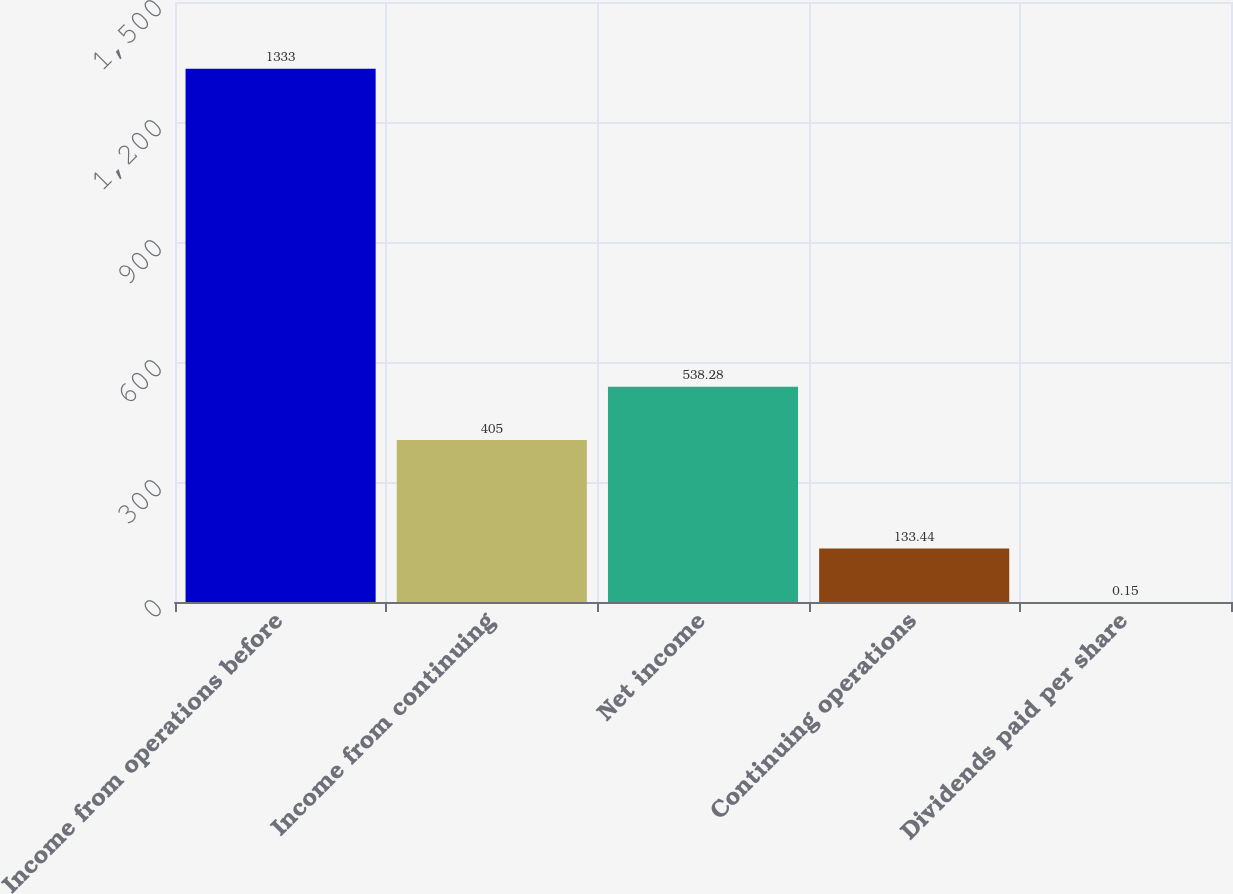Convert chart. <chart><loc_0><loc_0><loc_500><loc_500><bar_chart><fcel>Income from operations before<fcel>Income from continuing<fcel>Net income<fcel>Continuing operations<fcel>Dividends paid per share<nl><fcel>1333<fcel>405<fcel>538.28<fcel>133.44<fcel>0.15<nl></chart> 